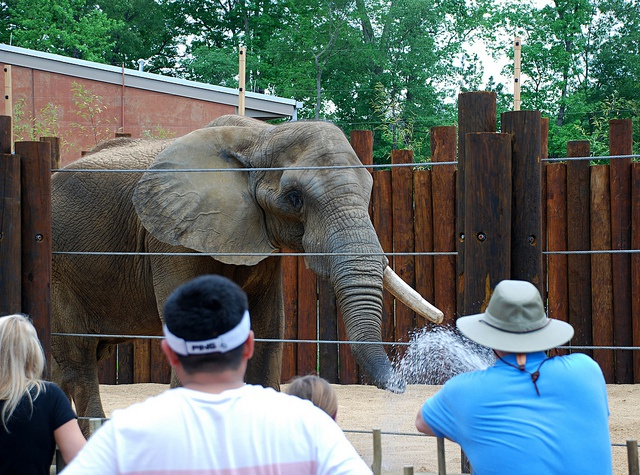Describe the objects in this image and their specific colors. I can see elephant in black, gray, and darkgray tones, people in black, white, gray, and navy tones, people in black and lightblue tones, people in black, darkgray, and gray tones, and people in black, gray, darkgray, and white tones in this image. 